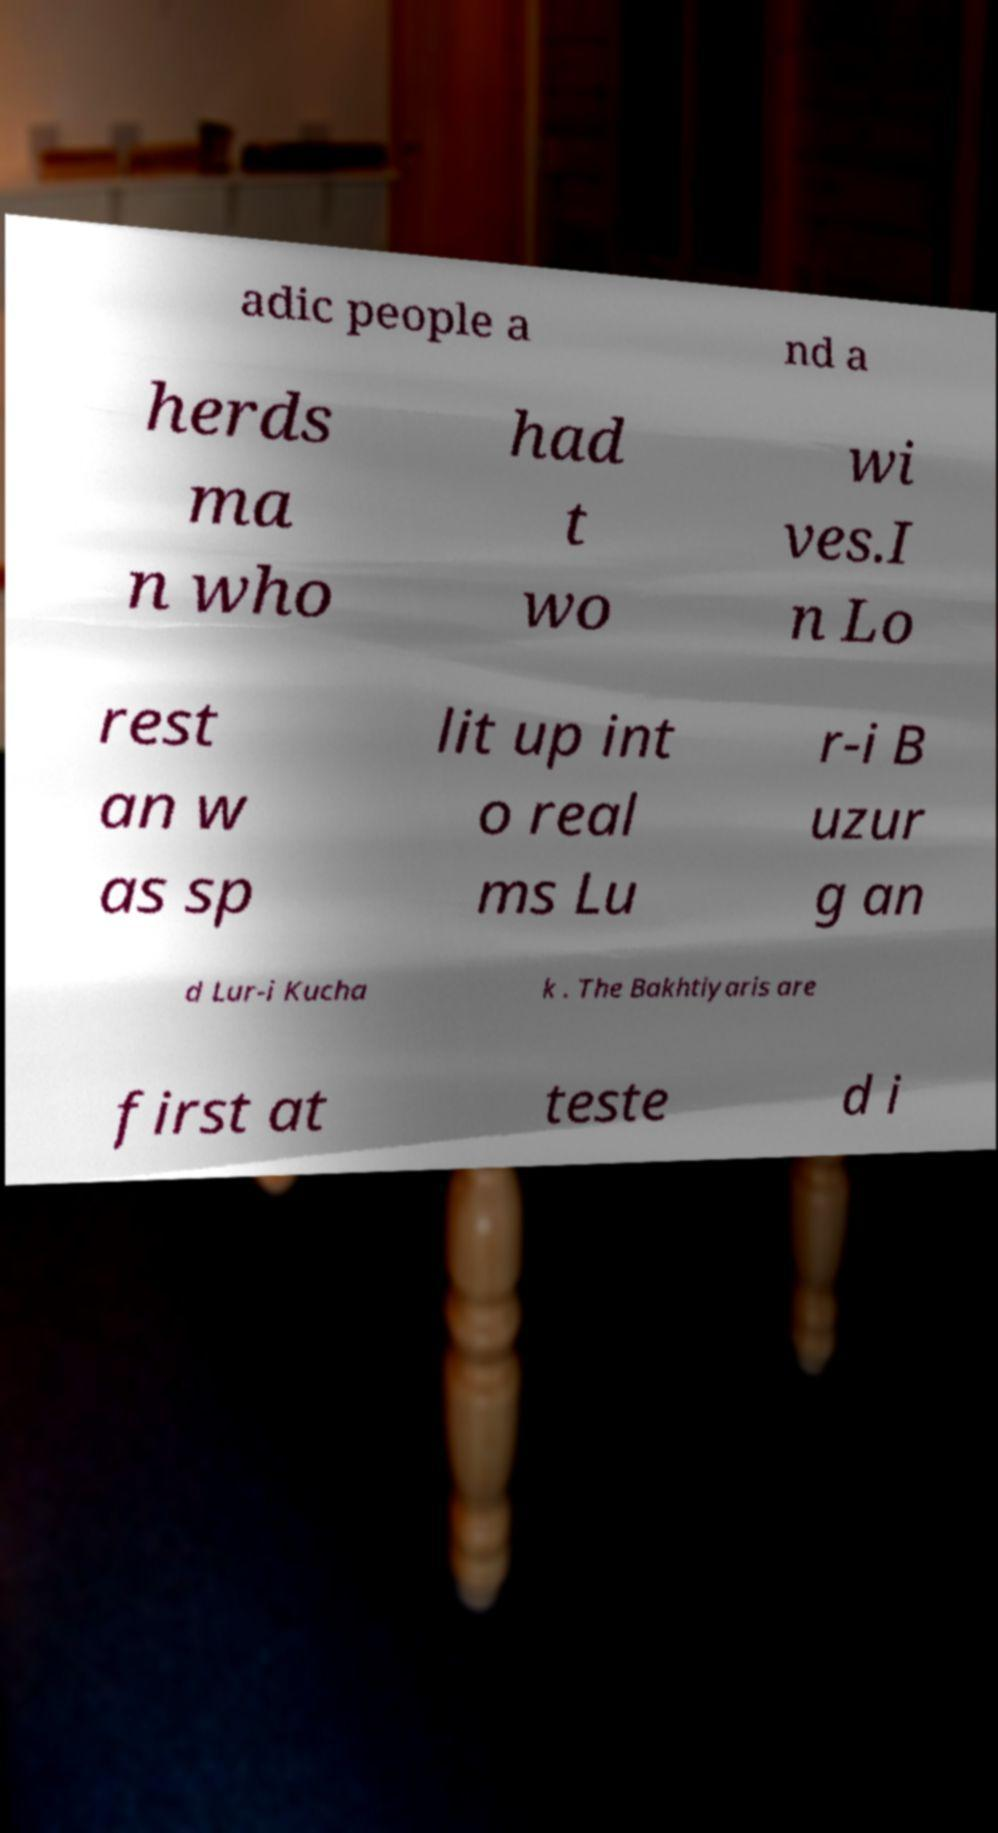For documentation purposes, I need the text within this image transcribed. Could you provide that? adic people a nd a herds ma n who had t wo wi ves.I n Lo rest an w as sp lit up int o real ms Lu r-i B uzur g an d Lur-i Kucha k . The Bakhtiyaris are first at teste d i 